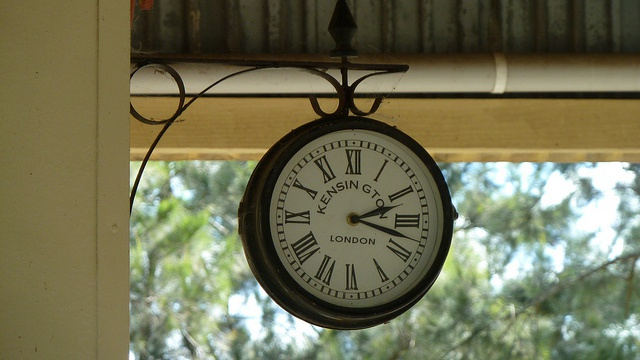Describe the objects in this image and their specific colors. I can see a clock in olive, gray, black, and darkgreen tones in this image. 